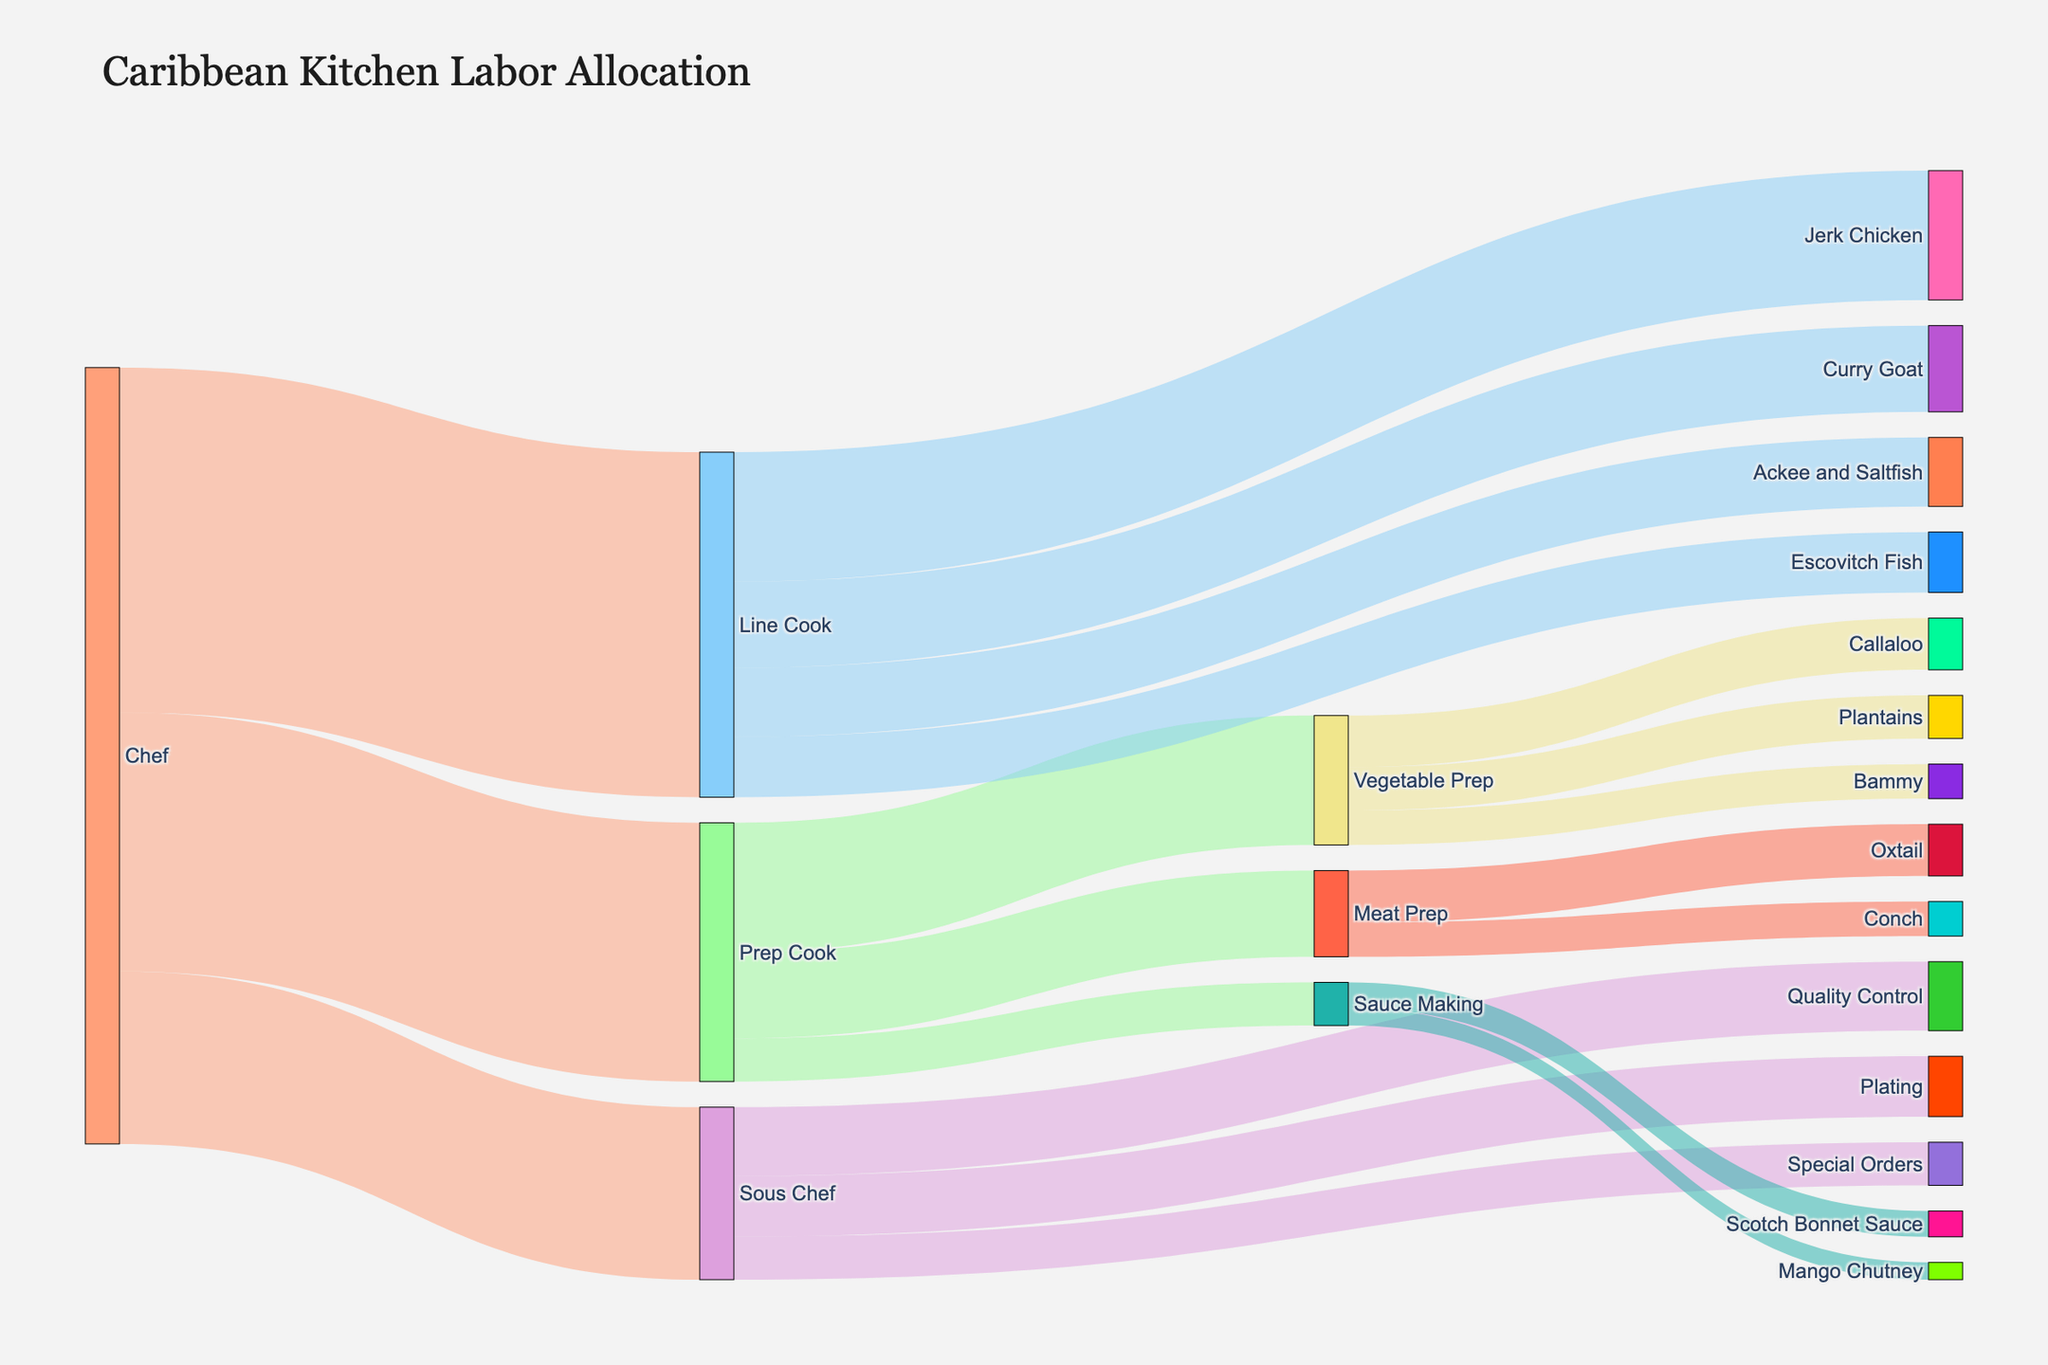What is the title of the Sankey Diagram? The title of the Sankey Diagram appears at the top of the figure. The title is typically a concise description of what the data represents.
Answer: Caribbean Kitchen Labor Allocation Which task is assigned the most value by Prep Cook? From the figure, follow the links originating from Prep Cook and compare their values. The task with the highest value connected to Prep Cook is the one assigned the most value.
Answer: Vegetable Prep How much total value does the Chef allocate to kitchen staff? Sum up the values of all the links originating from the Chef. Specifically, add the values assigned to Prep Cook, Line Cook, and Sous Chef. 30 + 40 + 20 = 90
Answer: 90 Which role handles the most tasks, excluding the Chef? Look for the role (excluding Chef) with the most targets branching out. Count the number of tasks that each role is connected to. The role with the most connections is the one handling the most tasks.
Answer: Prep Cook Compare the values assigned to Jerk Chicken and Escovitch Fish. Which one has a higher value? Identify the values assigned to both Jerk Chicken and Escovitch Fish from the figure. Compare these values to determine which one is higher. Jerk Chicken has a value of 15 and Escovitch Fish has a value of 7. 15 is higher than 7.
Answer: Jerk Chicken What is the total value assigned to different Sauce Making tasks? Sum up the values connected to Sauce Making (Scotch Bonnet Sauce and Mango Chutney). Add the values 3 and 2 together. 3 + 2 = 5
Answer: 5 Which specific Caribbean dish has the least value assigned to it by the Line Cook? Observe the values linked to the tasks handled by the Line Cook and identify the smallest value. This value represents the Caribbean dish with the least value assigned.
Answer: Escovitch Fish How much total value is assigned to vegetable-related tasks by Vegetable Prep? Sum the values for tasks handled by Vegetable Prep: Callaloo, Plantains, and Bammy. Add the values 6, 5, and 4 together. 6 + 5 + 4 = 15
Answer: 15 What is the combined value for tasks handled by the Sous Chef? Sum the values of all links leaving the Sous Chef: Quality Control, Plating, and Special Orders. 8 + 7 + 5 = 20
Answer: 20 Which specific task has the smallest value, and who is responsible for it? Identify all the values and find the smallest one. The smallest value in the figure is 2. Look at the link to see who is responsible for this task.
Answer: Mango Chutney, Sauce Making 